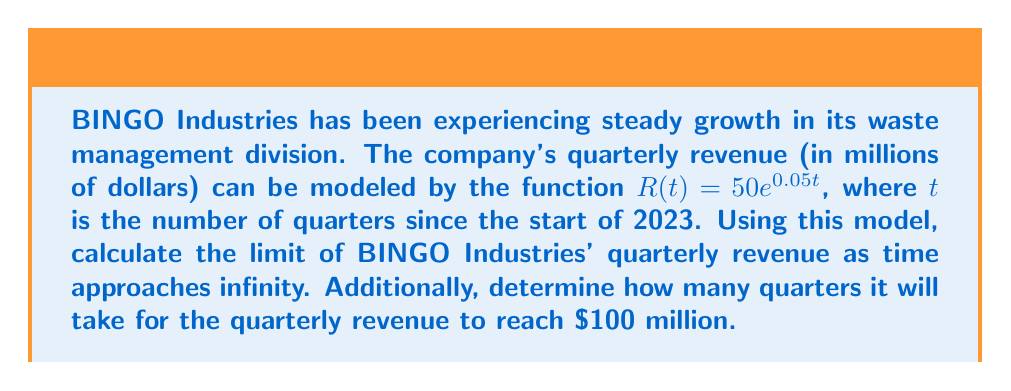Can you solve this math problem? To solve this problem, we'll break it down into two parts:

1. Calculating the limit of revenue as time approaches infinity:
   The revenue function is given by $R(t) = 50e^{0.05t}$
   
   To find the limit as $t$ approaches infinity:
   $$\lim_{t \to \infty} R(t) = \lim_{t \to \infty} 50e^{0.05t}$$
   
   As $t$ increases, $e^{0.05t}$ grows exponentially without bound.
   Therefore, $\lim_{t \to \infty} R(t) = \infty$

2. Determining when the quarterly revenue will reach $100 million:
   We need to solve the equation:
   $$100 = 50e^{0.05t}$$
   
   Dividing both sides by 50:
   $$2 = e^{0.05t}$$
   
   Taking the natural logarithm of both sides:
   $$\ln(2) = 0.05t$$
   
   Solving for $t$:
   $$t = \frac{\ln(2)}{0.05} \approx 13.86$$
   
   Since $t$ represents the number of quarters, we need to round up to the next whole number.
Answer: The limit of BINGO Industries' quarterly revenue as time approaches infinity is $\infty$. It will take 14 quarters for the quarterly revenue to reach or exceed $100 million. 